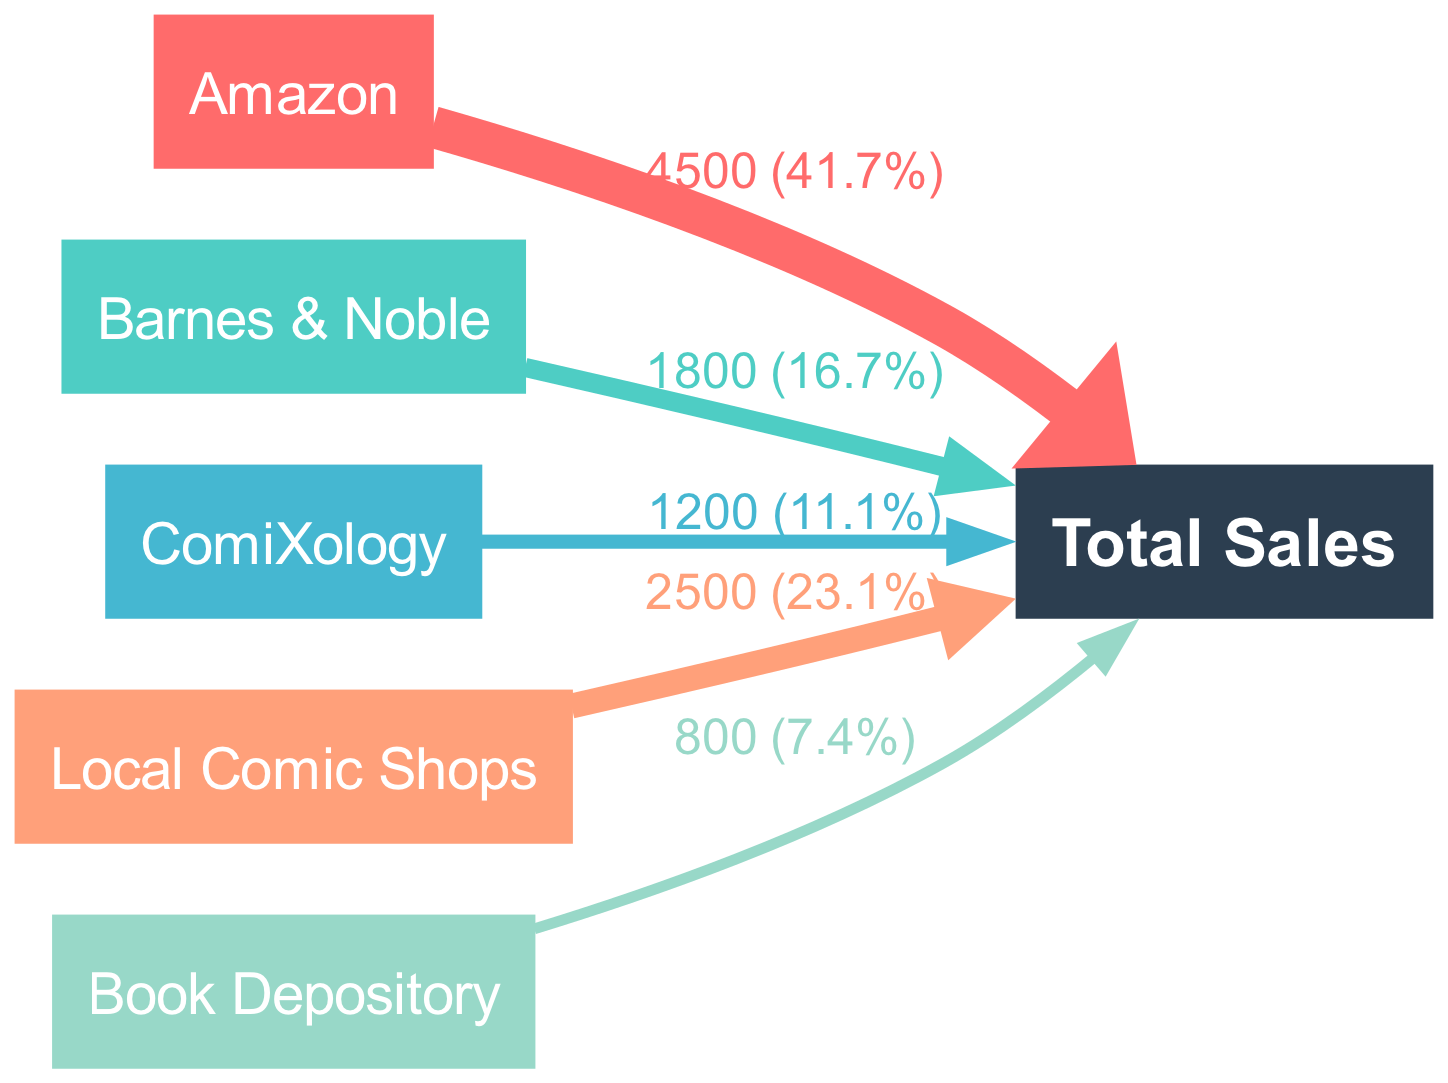What is the total sales value represented in the diagram? The total sales value is calculated by summing the values of all sales channels linked to the "Total Sales" node. The values are 4500 (Amazon) + 1800 (Barnes & Noble) + 1200 (ComiXology) + 2500 (Local Comic Shops) + 800 (Book Depository), totaling 10800.
Answer: 10800 How many different retailers are present in the diagram? The diagram lists five distinct retailers: Amazon, Barnes & Noble, ComiXology, Local Comic Shops, and Book Depository. Counting each unique retailer gives a total of five.
Answer: 5 Which retailer has the highest sales value? By examining the sales values linked to each retailer, Amazon has the highest sales value at 4500, compared to the others which show lower values.
Answer: Amazon What is the sales value from Local Comic Shops? The diagram shows that the sales value specifically linked to Local Comic Shops is 2500.
Answer: 2500 What percentage of total sales comes from ComiXology? To find the percentage, we take ComiXology's sales value of 1200 and divide it by the total sales of 10800, then multiply by 100, resulting in approximately 11.1%.
Answer: 11.1% Which retailer contributes the least to total sales? By comparing the sales values of all retailers, Book Depository has the lowest sales figure at 800, indicating it contributes the least to the total sales.
Answer: Book Depository How does the sales flow visually represent the relationships? The diagram visually shows the sales flow from each retailer as a colored path that connects to the "Total Sales" node, effectively demonstrating the contribution of each retailer to overall sales.
Answer: Through colored paths What is the total value of sales from online retailers (Amazon, Barnes & Noble, ComiXology, Book Depository)? Summing the sales values from the specified online retailers gives 4500 (Amazon) + 1800 (Barnes & Noble) + 1200 (ComiXology) + 800 (Book Depository) = 8300.
Answer: 8300 Which retailer accounts for 16.7% of total sales? To determine this, we see that Barnes & Noble contributes 1800. Calculating its share: (1800/10800) * 100 equals 16.7%, confirming its percentage representation.
Answer: Barnes & Noble 